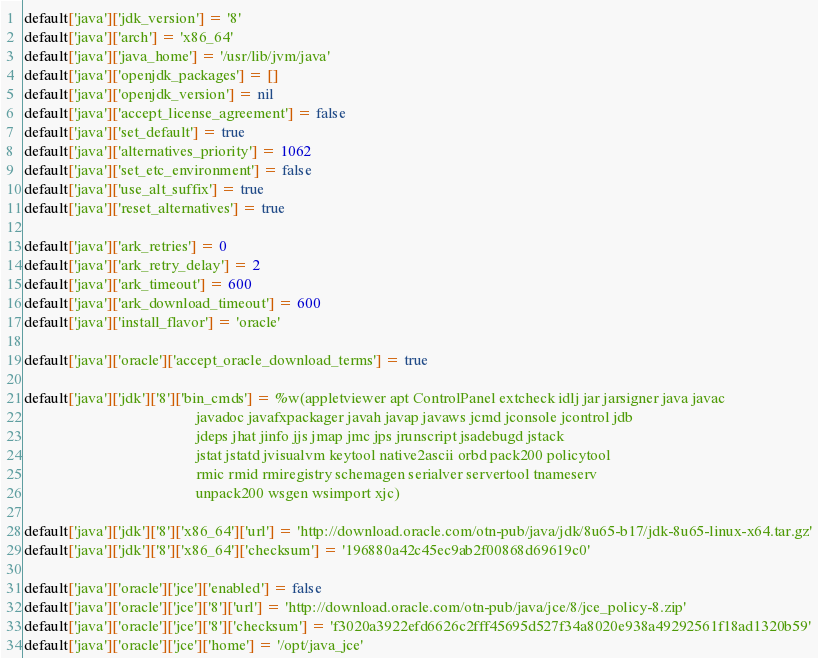<code> <loc_0><loc_0><loc_500><loc_500><_Ruby_>default['java']['jdk_version'] = '8'
default['java']['arch'] = 'x86_64'
default['java']['java_home'] = '/usr/lib/jvm/java'
default['java']['openjdk_packages'] = []
default['java']['openjdk_version'] = nil
default['java']['accept_license_agreement'] = false
default['java']['set_default'] = true
default['java']['alternatives_priority'] = 1062
default['java']['set_etc_environment'] = false
default['java']['use_alt_suffix'] = true
default['java']['reset_alternatives'] = true

default['java']['ark_retries'] = 0
default['java']['ark_retry_delay'] = 2
default['java']['ark_timeout'] = 600
default['java']['ark_download_timeout'] = 600
default['java']['install_flavor'] = 'oracle'

default['java']['oracle']['accept_oracle_download_terms'] = true

default['java']['jdk']['8']['bin_cmds'] = %w(appletviewer apt ControlPanel extcheck idlj jar jarsigner java javac
                                             javadoc javafxpackager javah javap javaws jcmd jconsole jcontrol jdb
                                             jdeps jhat jinfo jjs jmap jmc jps jrunscript jsadebugd jstack
                                             jstat jstatd jvisualvm keytool native2ascii orbd pack200 policytool
                                             rmic rmid rmiregistry schemagen serialver servertool tnameserv
                                             unpack200 wsgen wsimport xjc)

default['java']['jdk']['8']['x86_64']['url'] = 'http://download.oracle.com/otn-pub/java/jdk/8u65-b17/jdk-8u65-linux-x64.tar.gz'
default['java']['jdk']['8']['x86_64']['checksum'] = '196880a42c45ec9ab2f00868d69619c0'

default['java']['oracle']['jce']['enabled'] = false
default['java']['oracle']['jce']['8']['url'] = 'http://download.oracle.com/otn-pub/java/jce/8/jce_policy-8.zip'
default['java']['oracle']['jce']['8']['checksum'] = 'f3020a3922efd6626c2fff45695d527f34a8020e938a49292561f18ad1320b59'
default['java']['oracle']['jce']['home'] = '/opt/java_jce'
</code> 